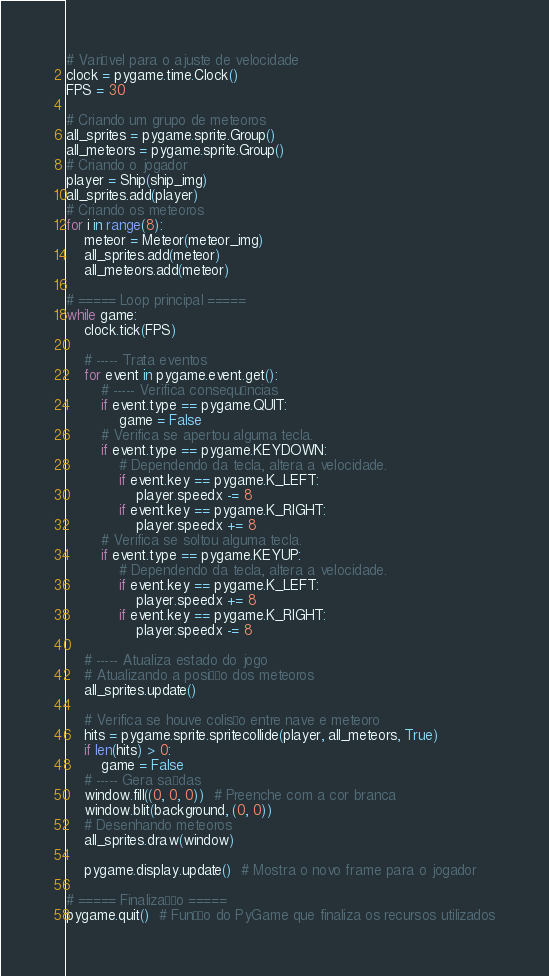Convert code to text. <code><loc_0><loc_0><loc_500><loc_500><_Python_># Variável para o ajuste de velocidade
clock = pygame.time.Clock()
FPS = 30

# Criando um grupo de meteoros
all_sprites = pygame.sprite.Group()
all_meteors = pygame.sprite.Group()
# Criando o jogador
player = Ship(ship_img)
all_sprites.add(player)
# Criando os meteoros
for i in range(8):
    meteor = Meteor(meteor_img)
    all_sprites.add(meteor)
    all_meteors.add(meteor)

# ===== Loop principal =====
while game:
    clock.tick(FPS)

    # ----- Trata eventos
    for event in pygame.event.get():
        # ----- Verifica consequências
        if event.type == pygame.QUIT:
            game = False
        # Verifica se apertou alguma tecla.
        if event.type == pygame.KEYDOWN:
            # Dependendo da tecla, altera a velocidade.
            if event.key == pygame.K_LEFT:
                player.speedx -= 8
            if event.key == pygame.K_RIGHT:
                player.speedx += 8
        # Verifica se soltou alguma tecla.
        if event.type == pygame.KEYUP:
            # Dependendo da tecla, altera a velocidade.
            if event.key == pygame.K_LEFT:
                player.speedx += 8
            if event.key == pygame.K_RIGHT:
                player.speedx -= 8

    # ----- Atualiza estado do jogo
    # Atualizando a posição dos meteoros
    all_sprites.update()

    # Verifica se houve colisão entre nave e meteoro
    hits = pygame.sprite.spritecollide(player, all_meteors, True)
    if len(hits) > 0:
        game = False
    # ----- Gera saídas
    window.fill((0, 0, 0))  # Preenche com a cor branca
    window.blit(background, (0, 0))
    # Desenhando meteoros
    all_sprites.draw(window)

    pygame.display.update()  # Mostra o novo frame para o jogador

# ===== Finalização =====
pygame.quit()  # Função do PyGame que finaliza os recursos utilizados

</code> 